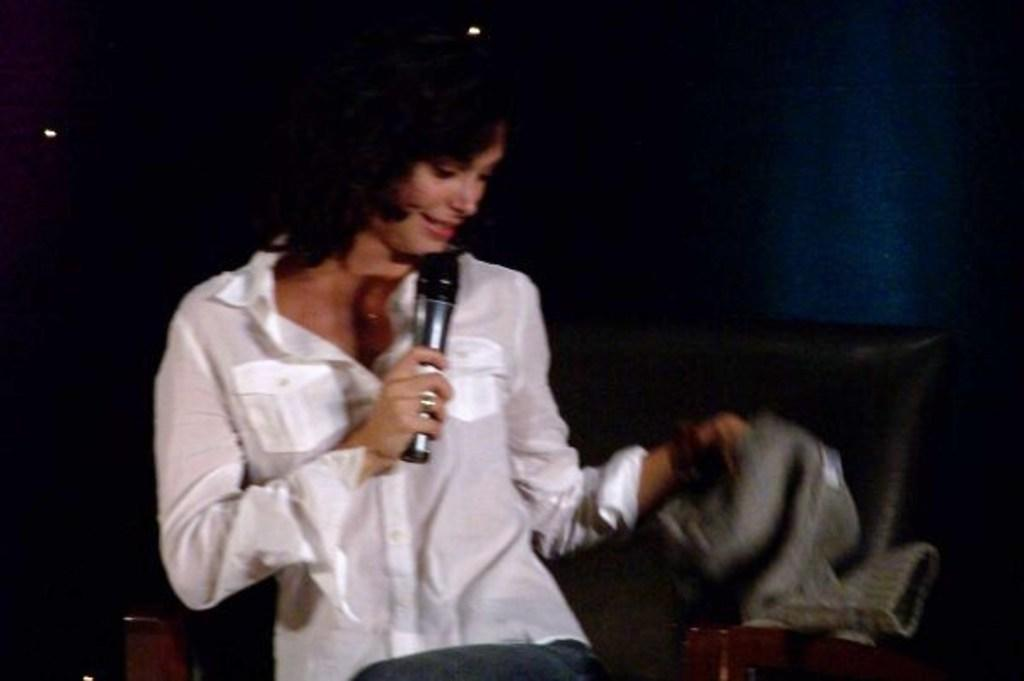Who is the main subject in the image? There is a woman in the image. What is the woman doing in the image? The woman is standing and singing into a microphone. What can be inferred about the setting of the image? The image was taken on a stage, and the background is dark. How many chickens are on the stage with the woman in the image? There are no chickens present in the image; it features a woman singing on a stage. What type of brush is the woman using to sing into the microphone? The woman is not using a brush to sing into the microphone; she is simply singing. 